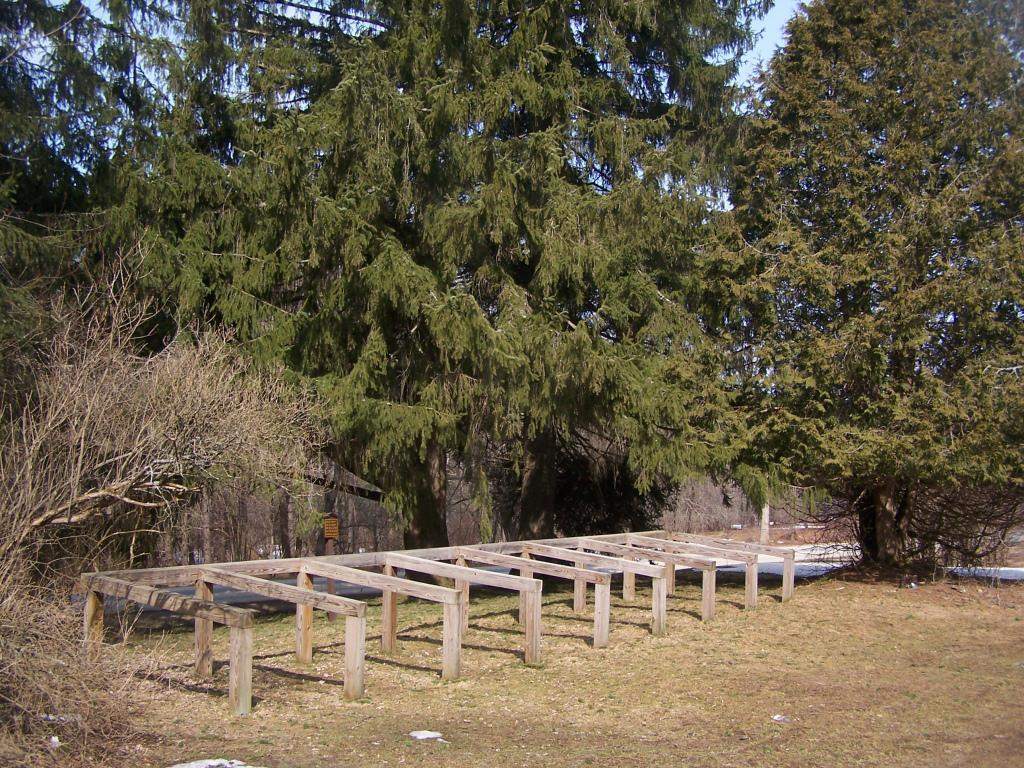What type of material is used to make the sticks in the image? The sticks in the image are made of wood. What type of vegetation is present in the image? There is grass and trees in the image. What part of the natural environment is visible in the image? The sky is visible in the image. What type of smoke can be seen coming from the trees in the image? There is no smoke present in the image; it features wooden sticks, grass, trees, and the sky. 